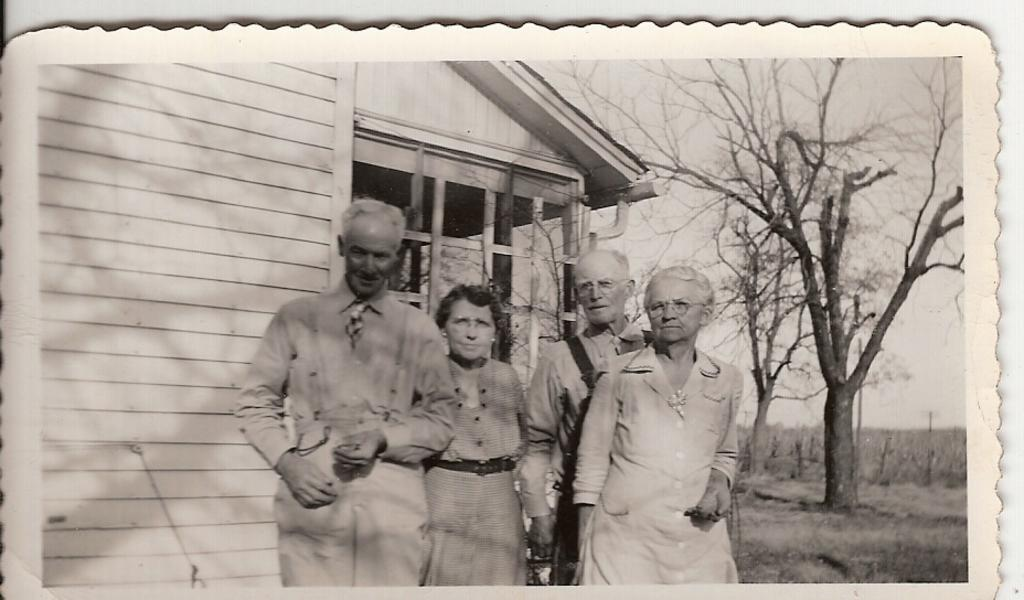What is the main subject of the image? There is a photo in the image. What can be seen in the photo? The photo contains people. What is visible in the background of the photo? There is a house, trees, grass, and the sky visible in the background of the photo. What is the color of the background of the image? The background of the image is white. Can you tell me how many yaks are visible in the photo? There are no yaks present in the photo; it features people and a background with a house, trees, grass, and the sky. What is the cause of the rabbit's sudden disappearance in the photo? There is no rabbit present in the photo, so it cannot be determined if there was a disappearance or a cause for it. 